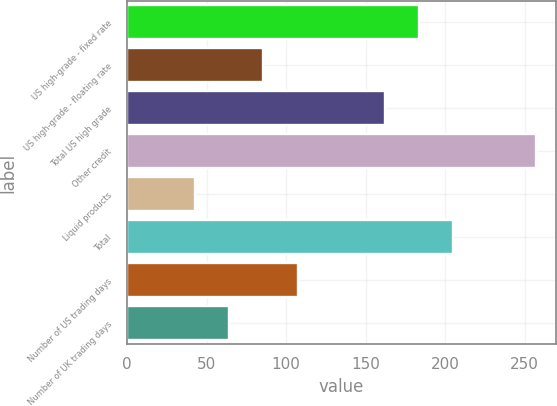Convert chart. <chart><loc_0><loc_0><loc_500><loc_500><bar_chart><fcel>US high-grade - fixed rate<fcel>US high-grade - floating rate<fcel>Total US high grade<fcel>Other credit<fcel>Liquid products<fcel>Total<fcel>Number of US trading days<fcel>Number of UK trading days<nl><fcel>183.4<fcel>85.8<fcel>162<fcel>257<fcel>43<fcel>204.8<fcel>107.2<fcel>64.4<nl></chart> 